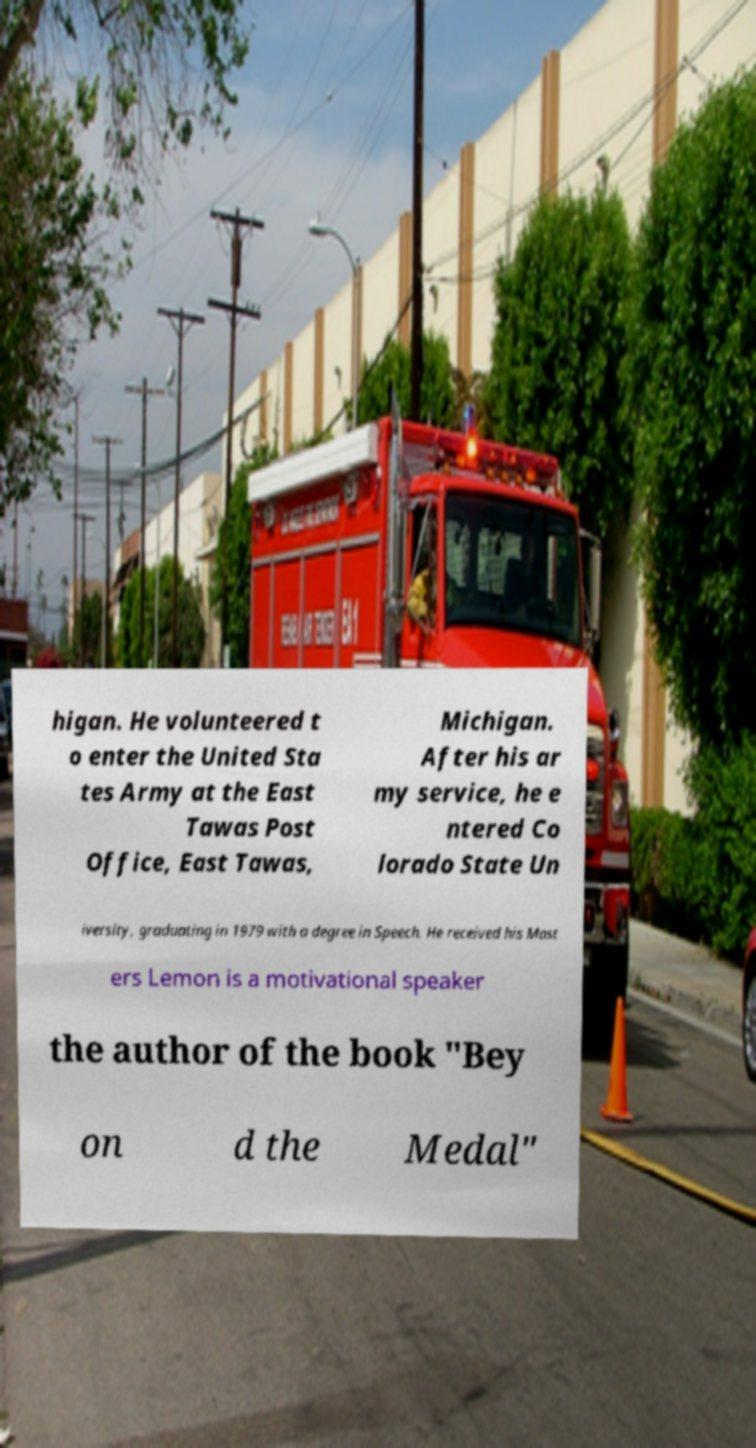I need the written content from this picture converted into text. Can you do that? higan. He volunteered t o enter the United Sta tes Army at the East Tawas Post Office, East Tawas, Michigan. After his ar my service, he e ntered Co lorado State Un iversity, graduating in 1979 with a degree in Speech. He received his Mast ers Lemon is a motivational speaker the author of the book "Bey on d the Medal" 